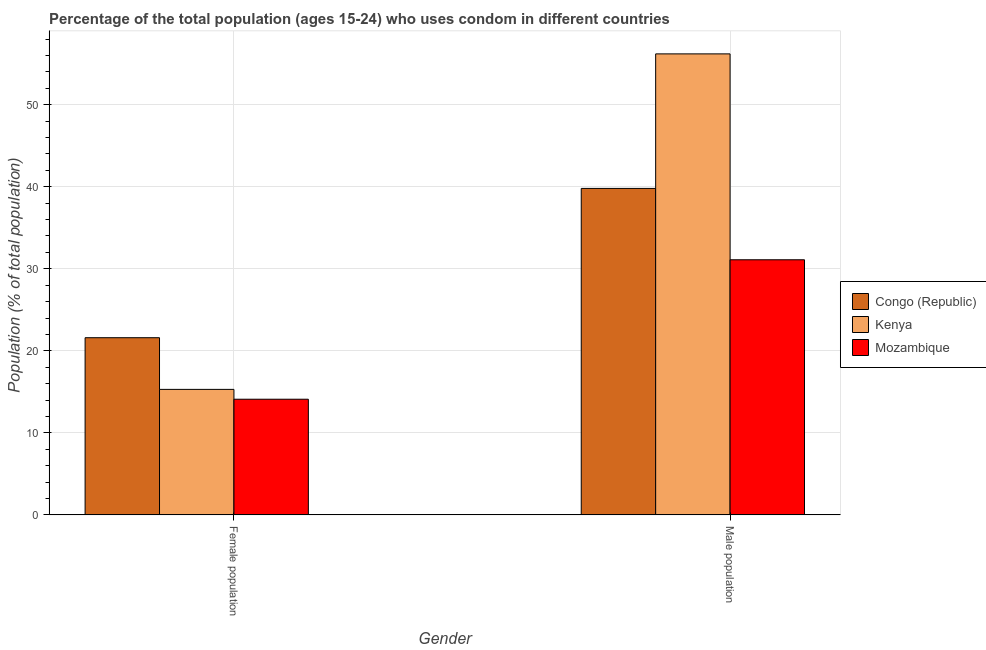Are the number of bars on each tick of the X-axis equal?
Ensure brevity in your answer.  Yes. How many bars are there on the 2nd tick from the left?
Your response must be concise. 3. What is the label of the 1st group of bars from the left?
Your answer should be compact. Female population. What is the male population in Mozambique?
Your answer should be very brief. 31.1. Across all countries, what is the maximum female population?
Your answer should be compact. 21.6. Across all countries, what is the minimum male population?
Provide a short and direct response. 31.1. In which country was the female population maximum?
Keep it short and to the point. Congo (Republic). In which country was the female population minimum?
Give a very brief answer. Mozambique. What is the total female population in the graph?
Provide a short and direct response. 51. What is the difference between the male population in Mozambique and that in Congo (Republic)?
Make the answer very short. -8.7. What is the difference between the female population in Congo (Republic) and the male population in Mozambique?
Make the answer very short. -9.5. What is the average female population per country?
Your answer should be very brief. 17. What is the difference between the male population and female population in Kenya?
Give a very brief answer. 40.9. What is the ratio of the female population in Mozambique to that in Kenya?
Provide a succinct answer. 0.92. Is the female population in Mozambique less than that in Kenya?
Provide a succinct answer. Yes. In how many countries, is the female population greater than the average female population taken over all countries?
Give a very brief answer. 1. What does the 3rd bar from the left in Female population represents?
Your answer should be very brief. Mozambique. What does the 1st bar from the right in Female population represents?
Make the answer very short. Mozambique. How many countries are there in the graph?
Provide a succinct answer. 3. What is the difference between two consecutive major ticks on the Y-axis?
Offer a terse response. 10. Are the values on the major ticks of Y-axis written in scientific E-notation?
Provide a short and direct response. No. What is the title of the graph?
Provide a short and direct response. Percentage of the total population (ages 15-24) who uses condom in different countries. Does "St. Martin (French part)" appear as one of the legend labels in the graph?
Offer a very short reply. No. What is the label or title of the X-axis?
Offer a very short reply. Gender. What is the label or title of the Y-axis?
Ensure brevity in your answer.  Population (% of total population) . What is the Population (% of total population)  in Congo (Republic) in Female population?
Make the answer very short. 21.6. What is the Population (% of total population)  of Congo (Republic) in Male population?
Provide a succinct answer. 39.8. What is the Population (% of total population)  of Kenya in Male population?
Your response must be concise. 56.2. What is the Population (% of total population)  in Mozambique in Male population?
Your answer should be very brief. 31.1. Across all Gender, what is the maximum Population (% of total population)  of Congo (Republic)?
Your answer should be very brief. 39.8. Across all Gender, what is the maximum Population (% of total population)  of Kenya?
Your answer should be compact. 56.2. Across all Gender, what is the maximum Population (% of total population)  in Mozambique?
Provide a short and direct response. 31.1. Across all Gender, what is the minimum Population (% of total population)  of Congo (Republic)?
Give a very brief answer. 21.6. What is the total Population (% of total population)  of Congo (Republic) in the graph?
Provide a succinct answer. 61.4. What is the total Population (% of total population)  in Kenya in the graph?
Provide a short and direct response. 71.5. What is the total Population (% of total population)  in Mozambique in the graph?
Offer a terse response. 45.2. What is the difference between the Population (% of total population)  of Congo (Republic) in Female population and that in Male population?
Your answer should be very brief. -18.2. What is the difference between the Population (% of total population)  of Kenya in Female population and that in Male population?
Your answer should be very brief. -40.9. What is the difference between the Population (% of total population)  in Mozambique in Female population and that in Male population?
Keep it short and to the point. -17. What is the difference between the Population (% of total population)  in Congo (Republic) in Female population and the Population (% of total population)  in Kenya in Male population?
Give a very brief answer. -34.6. What is the difference between the Population (% of total population)  in Congo (Republic) in Female population and the Population (% of total population)  in Mozambique in Male population?
Your answer should be compact. -9.5. What is the difference between the Population (% of total population)  in Kenya in Female population and the Population (% of total population)  in Mozambique in Male population?
Offer a very short reply. -15.8. What is the average Population (% of total population)  in Congo (Republic) per Gender?
Offer a very short reply. 30.7. What is the average Population (% of total population)  of Kenya per Gender?
Ensure brevity in your answer.  35.75. What is the average Population (% of total population)  in Mozambique per Gender?
Your answer should be very brief. 22.6. What is the difference between the Population (% of total population)  of Congo (Republic) and Population (% of total population)  of Kenya in Female population?
Your answer should be very brief. 6.3. What is the difference between the Population (% of total population)  in Congo (Republic) and Population (% of total population)  in Kenya in Male population?
Offer a very short reply. -16.4. What is the difference between the Population (% of total population)  of Kenya and Population (% of total population)  of Mozambique in Male population?
Offer a very short reply. 25.1. What is the ratio of the Population (% of total population)  in Congo (Republic) in Female population to that in Male population?
Ensure brevity in your answer.  0.54. What is the ratio of the Population (% of total population)  of Kenya in Female population to that in Male population?
Your answer should be compact. 0.27. What is the ratio of the Population (% of total population)  in Mozambique in Female population to that in Male population?
Ensure brevity in your answer.  0.45. What is the difference between the highest and the second highest Population (% of total population)  in Kenya?
Your answer should be very brief. 40.9. What is the difference between the highest and the second highest Population (% of total population)  of Mozambique?
Offer a very short reply. 17. What is the difference between the highest and the lowest Population (% of total population)  of Congo (Republic)?
Your response must be concise. 18.2. What is the difference between the highest and the lowest Population (% of total population)  of Kenya?
Provide a succinct answer. 40.9. 